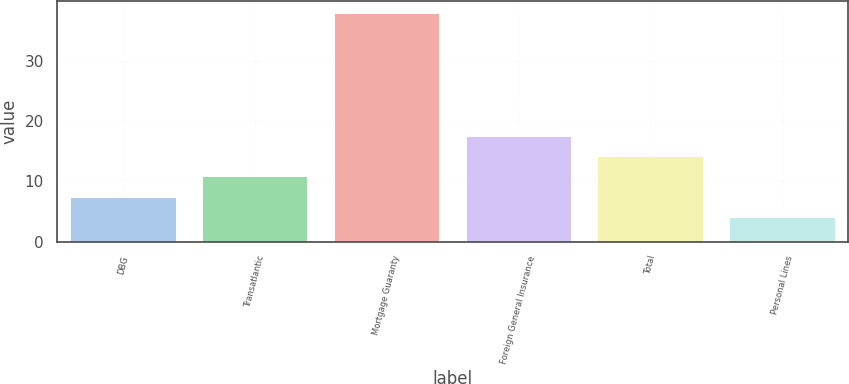Convert chart to OTSL. <chart><loc_0><loc_0><loc_500><loc_500><bar_chart><fcel>DBG<fcel>Transatlantic<fcel>Mortgage Guaranty<fcel>Foreign General Insurance<fcel>Total<fcel>Personal Lines<nl><fcel>7.4<fcel>10.8<fcel>38<fcel>17.6<fcel>14.2<fcel>4<nl></chart> 